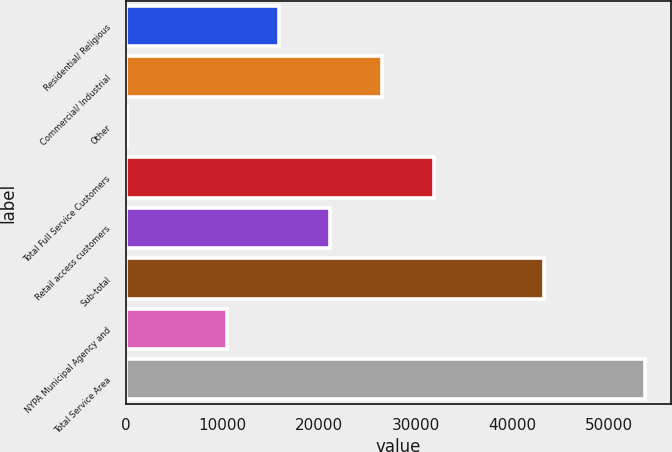Convert chart to OTSL. <chart><loc_0><loc_0><loc_500><loc_500><bar_chart><fcel>Residential/ Religious<fcel>Commercial/ Industrial<fcel>Other<fcel>Total Full Service Customers<fcel>Retail access customers<fcel>Sub-total<fcel>NYPA Municipal Agency and<fcel>Total Service Area<nl><fcel>15828.1<fcel>26544.3<fcel>154<fcel>31902.4<fcel>21186.2<fcel>43265<fcel>10470<fcel>53735<nl></chart> 